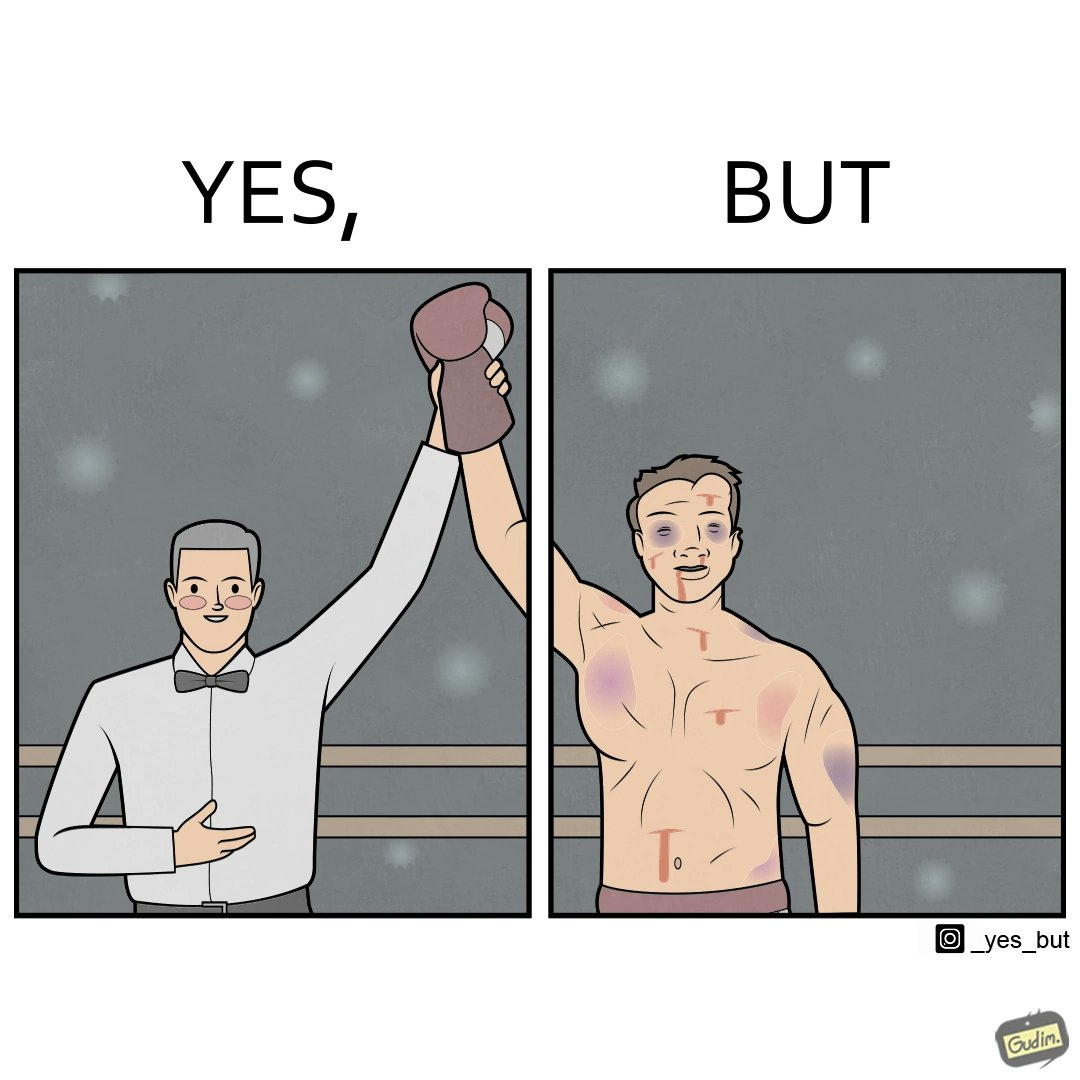Describe the contrast between the left and right parts of this image. In the left part of the image: a referee announcing the winner of a boxing match. In the right part of the image: a bruised boxer. 